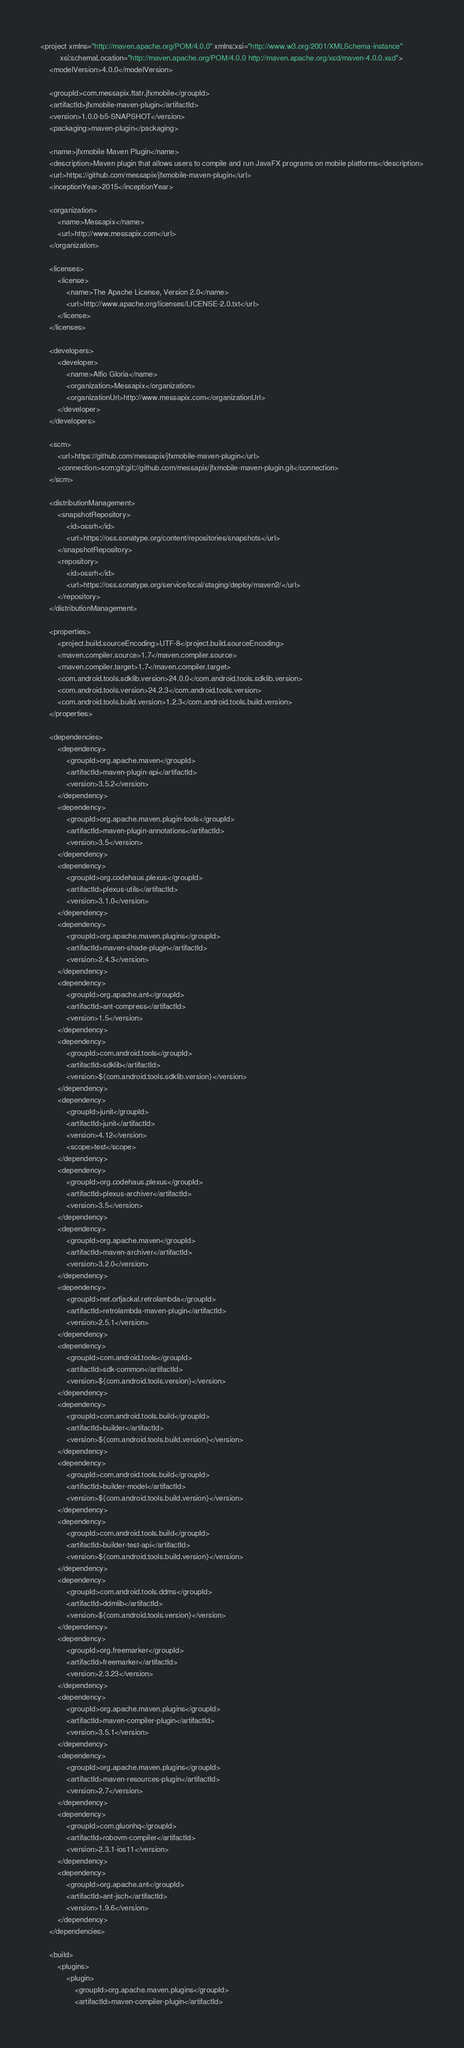Convert code to text. <code><loc_0><loc_0><loc_500><loc_500><_XML_><project xmlns="http://maven.apache.org/POM/4.0.0" xmlns:xsi="http://www.w3.org/2001/XMLSchema-instance"
         xsi:schemaLocation="http://maven.apache.org/POM/4.0.0 http://maven.apache.org/xsd/maven-4.0.0.xsd">
    <modelVersion>4.0.0</modelVersion>

    <groupId>com.messapix.ftatr.jfxmobile</groupId>
    <artifactId>jfxmobile-maven-plugin</artifactId>
    <version>1.0.0-b5-SNAPSHOT</version>
    <packaging>maven-plugin</packaging>

    <name>jfxmobile Maven Plugin</name>
    <description>Maven plugin that allows users to compile and run JavaFX programs on mobile platforms</description>
    <url>https://github.com/messapix/jfxmobile-maven-plugin</url>
    <inceptionYear>2015</inceptionYear>
    
    <organization>
        <name>Messapix</name>
        <url>http://www.messapix.com</url>
    </organization>
    
    <licenses>
        <license>
            <name>The Apache License, Version 2.0</name>
            <url>http://www.apache.org/licenses/LICENSE-2.0.txt</url>
        </license>
    </licenses>
    
    <developers>
        <developer>
            <name>Alfio Gloria</name>
            <organization>Messapix</organization>
            <organizationUrl>http://www.messapix.com</organizationUrl>
        </developer>
    </developers>
    
    <scm>
        <url>https://github.com/messapix/jfxmobile-maven-plugin</url>
        <connection>scm:git:git://github.com/messapix/jfxmobile-maven-plugin.git</connection>
    </scm>
    
    <distributionManagement>
        <snapshotRepository>
            <id>ossrh</id>
            <url>https://oss.sonatype.org/content/repositories/snapshots</url>
        </snapshotRepository>
        <repository>
            <id>ossrh</id>
            <url>https://oss.sonatype.org/service/local/staging/deploy/maven2/</url>
        </repository>
    </distributionManagement>

    <properties>
        <project.build.sourceEncoding>UTF-8</project.build.sourceEncoding>
        <maven.compiler.source>1.7</maven.compiler.source>
        <maven.compiler.target>1.7</maven.compiler.target>
        <com.android.tools.sdklib.version>24.0.0</com.android.tools.sdklib.version>
        <com.android.tools.version>24.2.3</com.android.tools.version>
        <com.android.tools.build.version>1.2.3</com.android.tools.build.version>
    </properties>

    <dependencies>
        <dependency>
            <groupId>org.apache.maven</groupId>
            <artifactId>maven-plugin-api</artifactId>
            <version>3.5.2</version>
        </dependency>
        <dependency>
            <groupId>org.apache.maven.plugin-tools</groupId>
            <artifactId>maven-plugin-annotations</artifactId>
            <version>3.5</version>
        </dependency>
        <dependency>
            <groupId>org.codehaus.plexus</groupId>
            <artifactId>plexus-utils</artifactId>
            <version>3.1.0</version>
        </dependency>
        <dependency>
            <groupId>org.apache.maven.plugins</groupId>
            <artifactId>maven-shade-plugin</artifactId>
            <version>2.4.3</version>
        </dependency>
        <dependency>
            <groupId>org.apache.ant</groupId>
            <artifactId>ant-compress</artifactId>
            <version>1.5</version>
        </dependency>
        <dependency>
            <groupId>com.android.tools</groupId>
            <artifactId>sdklib</artifactId>
            <version>${com.android.tools.sdklib.version}</version>
        </dependency>
        <dependency>
            <groupId>junit</groupId>
            <artifactId>junit</artifactId>
            <version>4.12</version>
            <scope>test</scope>
        </dependency>
        <dependency>
            <groupId>org.codehaus.plexus</groupId>
            <artifactId>plexus-archiver</artifactId>
            <version>3.5</version>
        </dependency>
        <dependency>
            <groupId>org.apache.maven</groupId>
            <artifactId>maven-archiver</artifactId>
            <version>3.2.0</version>
        </dependency>
        <dependency>
            <groupId>net.orfjackal.retrolambda</groupId>
            <artifactId>retrolambda-maven-plugin</artifactId>
            <version>2.5.1</version>
        </dependency>    
        <dependency>
            <groupId>com.android.tools</groupId>
            <artifactId>sdk-common</artifactId>
            <version>${com.android.tools.version}</version>
        </dependency>
        <dependency>
            <groupId>com.android.tools.build</groupId>
            <artifactId>builder</artifactId>
            <version>${com.android.tools.build.version}</version>
        </dependency>
        <dependency>
            <groupId>com.android.tools.build</groupId>
            <artifactId>builder-model</artifactId>
            <version>${com.android.tools.build.version}</version>
        </dependency>
        <dependency>
            <groupId>com.android.tools.build</groupId>
            <artifactId>builder-test-api</artifactId>
            <version>${com.android.tools.build.version}</version>
        </dependency>
        <dependency>
            <groupId>com.android.tools.ddms</groupId>
            <artifactId>ddmlib</artifactId>
            <version>${com.android.tools.version}</version>
        </dependency>
        <dependency>
            <groupId>org.freemarker</groupId>
            <artifactId>freemarker</artifactId>
            <version>2.3.23</version>
        </dependency>
        <dependency>
            <groupId>org.apache.maven.plugins</groupId>
            <artifactId>maven-compiler-plugin</artifactId>
            <version>3.5.1</version>
        </dependency>
        <dependency>
            <groupId>org.apache.maven.plugins</groupId>
            <artifactId>maven-resources-plugin</artifactId>
            <version>2.7</version>
        </dependency>
        <dependency>
            <groupId>com.gluonhq</groupId>
            <artifactId>robovm-compiler</artifactId>
            <version>2.3.1-ios11</version>
        </dependency>
        <dependency>
            <groupId>org.apache.ant</groupId>
            <artifactId>ant-jsch</artifactId>
            <version>1.9.6</version>
        </dependency>
    </dependencies>
    
    <build>
        <plugins>
            <plugin>
                <groupId>org.apache.maven.plugins</groupId>
                <artifactId>maven-compiler-plugin</artifactId></code> 